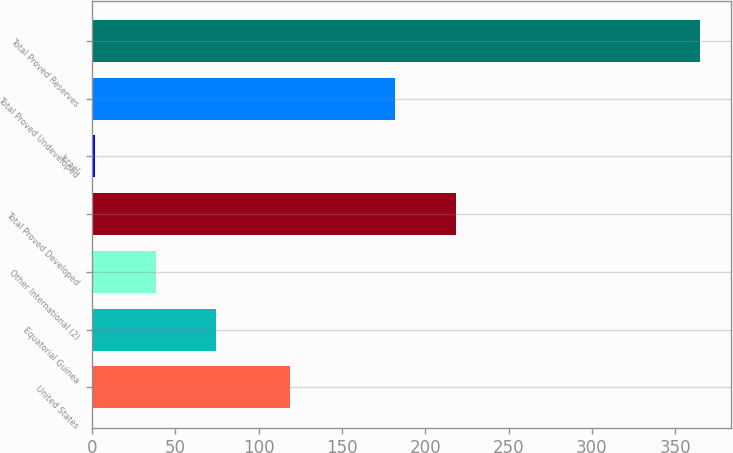Convert chart. <chart><loc_0><loc_0><loc_500><loc_500><bar_chart><fcel>United States<fcel>Equatorial Guinea<fcel>Other International (2)<fcel>Total Proved Developed<fcel>Israel<fcel>Total Proved Undeveloped<fcel>Total Proved Reserves<nl><fcel>119<fcel>74.6<fcel>38.3<fcel>218.3<fcel>2<fcel>182<fcel>365<nl></chart> 